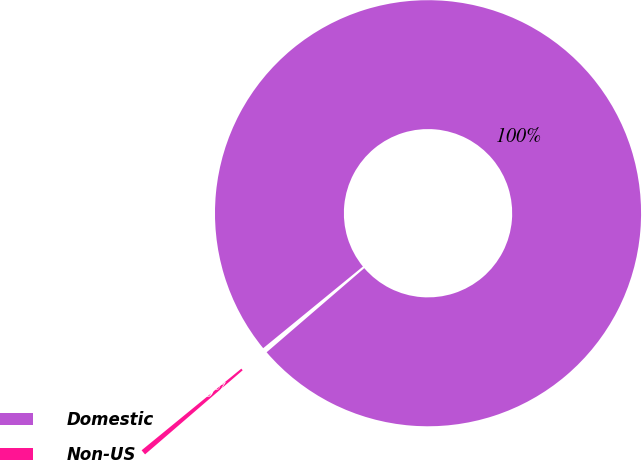<chart> <loc_0><loc_0><loc_500><loc_500><pie_chart><fcel>Domestic<fcel>Non-US<nl><fcel>99.6%<fcel>0.4%<nl></chart> 